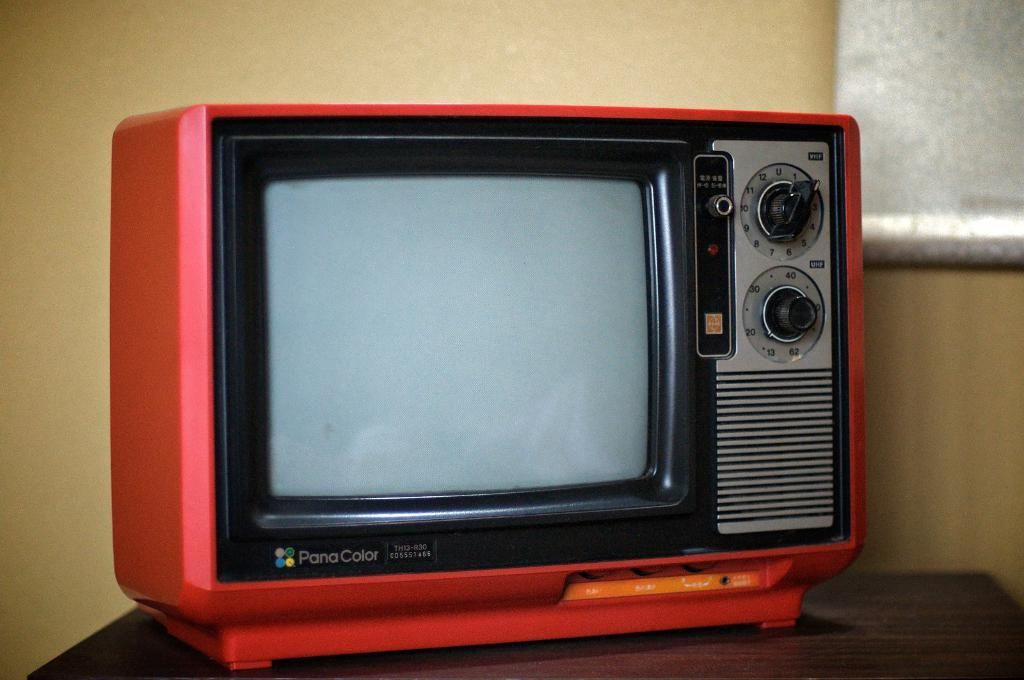<image>
Provide a brief description of the given image. A small red tube television from PanaColor sits on a stand. 